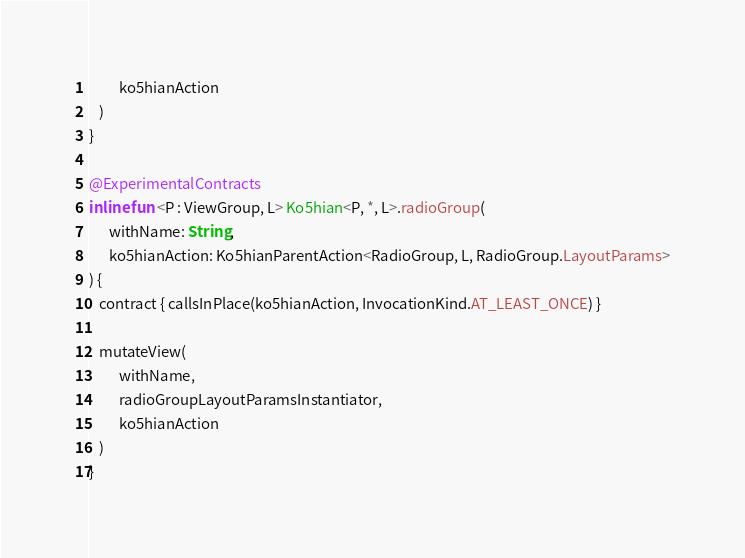Convert code to text. <code><loc_0><loc_0><loc_500><loc_500><_Kotlin_>         ko5hianAction
   )
}

@ExperimentalContracts
inline fun <P : ViewGroup, L> Ko5hian<P, *, L>.radioGroup(
      withName: String,
      ko5hianAction: Ko5hianParentAction<RadioGroup, L, RadioGroup.LayoutParams>
) {
   contract { callsInPlace(ko5hianAction, InvocationKind.AT_LEAST_ONCE) }

   mutateView(
         withName,
         radioGroupLayoutParamsInstantiator,
         ko5hianAction
   )
}
</code> 